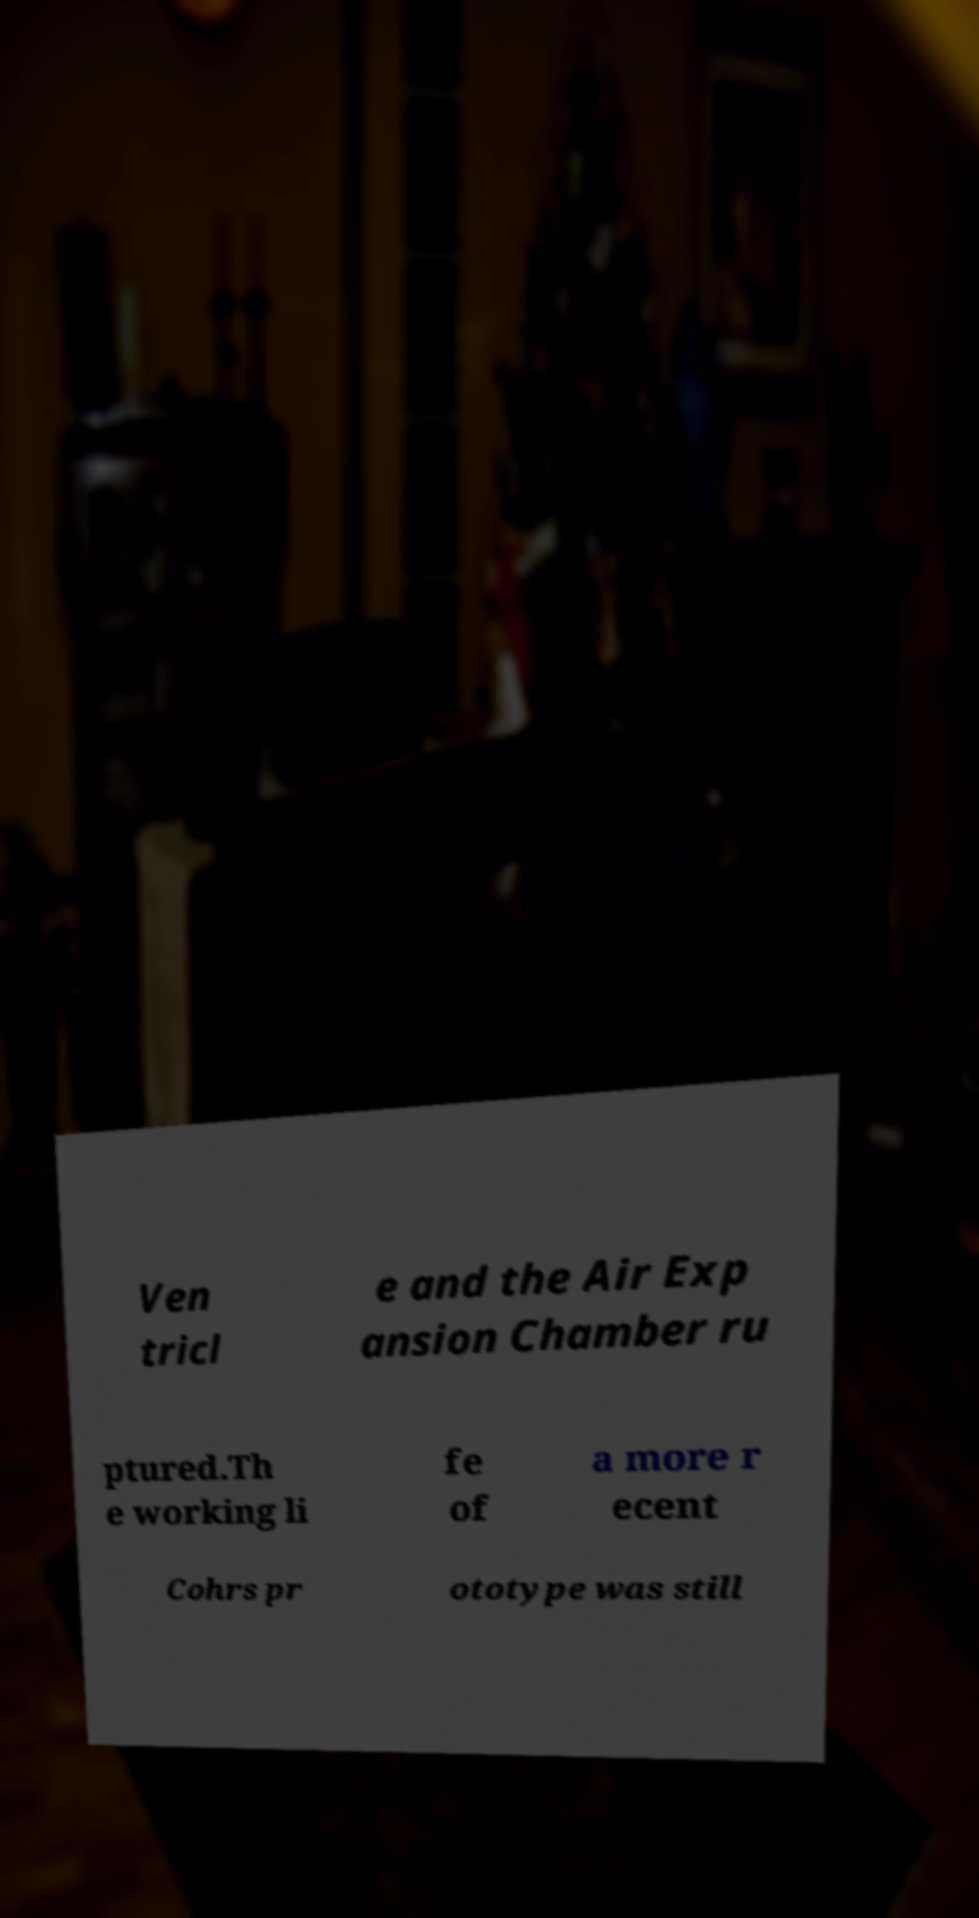There's text embedded in this image that I need extracted. Can you transcribe it verbatim? Ven tricl e and the Air Exp ansion Chamber ru ptured.Th e working li fe of a more r ecent Cohrs pr ototype was still 